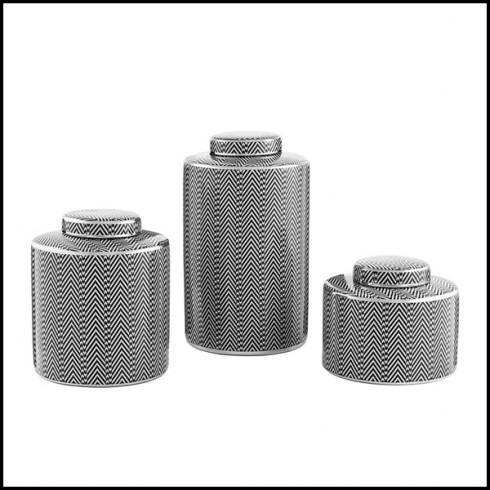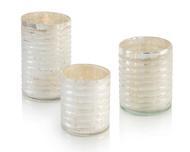The first image is the image on the left, the second image is the image on the right. For the images displayed, is the sentence "there are dark fluted vases and hammered textured ones" factually correct? Answer yes or no. No. 